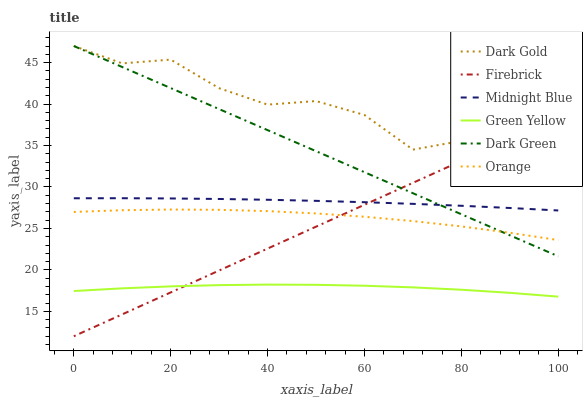Does Green Yellow have the minimum area under the curve?
Answer yes or no. Yes. Does Dark Gold have the maximum area under the curve?
Answer yes or no. Yes. Does Firebrick have the minimum area under the curve?
Answer yes or no. No. Does Firebrick have the maximum area under the curve?
Answer yes or no. No. Is Dark Green the smoothest?
Answer yes or no. Yes. Is Dark Gold the roughest?
Answer yes or no. Yes. Is Firebrick the smoothest?
Answer yes or no. No. Is Firebrick the roughest?
Answer yes or no. No. Does Firebrick have the lowest value?
Answer yes or no. Yes. Does Dark Gold have the lowest value?
Answer yes or no. No. Does Dark Green have the highest value?
Answer yes or no. Yes. Does Firebrick have the highest value?
Answer yes or no. No. Is Green Yellow less than Orange?
Answer yes or no. Yes. Is Dark Gold greater than Green Yellow?
Answer yes or no. Yes. Does Firebrick intersect Dark Gold?
Answer yes or no. Yes. Is Firebrick less than Dark Gold?
Answer yes or no. No. Is Firebrick greater than Dark Gold?
Answer yes or no. No. Does Green Yellow intersect Orange?
Answer yes or no. No. 